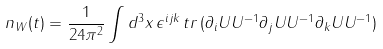<formula> <loc_0><loc_0><loc_500><loc_500>n _ { W } ( t ) = \frac { 1 } { 2 4 \pi ^ { 2 } } \int d ^ { 3 } x \, \epsilon ^ { i j k } \, t r \, ( \partial _ { i } U U ^ { - 1 } \partial _ { j } U U ^ { - 1 } \partial _ { k } U U ^ { - 1 } )</formula> 